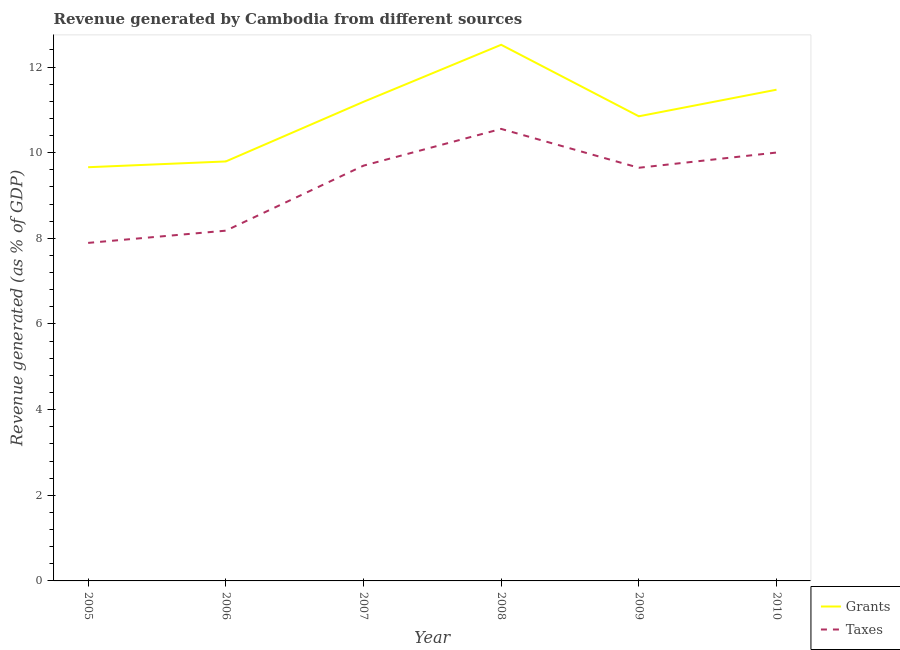How many different coloured lines are there?
Offer a very short reply. 2. Is the number of lines equal to the number of legend labels?
Your response must be concise. Yes. What is the revenue generated by grants in 2006?
Provide a short and direct response. 9.8. Across all years, what is the maximum revenue generated by grants?
Ensure brevity in your answer.  12.52. Across all years, what is the minimum revenue generated by grants?
Ensure brevity in your answer.  9.66. What is the total revenue generated by grants in the graph?
Offer a terse response. 65.48. What is the difference between the revenue generated by taxes in 2006 and that in 2010?
Your response must be concise. -1.82. What is the difference between the revenue generated by grants in 2007 and the revenue generated by taxes in 2010?
Give a very brief answer. 1.18. What is the average revenue generated by taxes per year?
Your answer should be very brief. 9.33. In the year 2008, what is the difference between the revenue generated by grants and revenue generated by taxes?
Offer a very short reply. 1.96. In how many years, is the revenue generated by taxes greater than 4 %?
Provide a short and direct response. 6. What is the ratio of the revenue generated by taxes in 2006 to that in 2007?
Ensure brevity in your answer.  0.84. Is the revenue generated by grants in 2005 less than that in 2006?
Make the answer very short. Yes. Is the difference between the revenue generated by taxes in 2006 and 2008 greater than the difference between the revenue generated by grants in 2006 and 2008?
Provide a short and direct response. Yes. What is the difference between the highest and the second highest revenue generated by grants?
Provide a short and direct response. 1.05. What is the difference between the highest and the lowest revenue generated by taxes?
Keep it short and to the point. 2.66. Is the revenue generated by grants strictly less than the revenue generated by taxes over the years?
Your response must be concise. No. How many lines are there?
Your answer should be compact. 2. How many years are there in the graph?
Keep it short and to the point. 6. Does the graph contain grids?
Make the answer very short. No. Where does the legend appear in the graph?
Ensure brevity in your answer.  Bottom right. How are the legend labels stacked?
Ensure brevity in your answer.  Vertical. What is the title of the graph?
Your answer should be compact. Revenue generated by Cambodia from different sources. What is the label or title of the Y-axis?
Provide a succinct answer. Revenue generated (as % of GDP). What is the Revenue generated (as % of GDP) in Grants in 2005?
Make the answer very short. 9.66. What is the Revenue generated (as % of GDP) of Taxes in 2005?
Offer a terse response. 7.89. What is the Revenue generated (as % of GDP) in Grants in 2006?
Keep it short and to the point. 9.8. What is the Revenue generated (as % of GDP) in Taxes in 2006?
Your answer should be compact. 8.18. What is the Revenue generated (as % of GDP) of Grants in 2007?
Your response must be concise. 11.19. What is the Revenue generated (as % of GDP) of Taxes in 2007?
Your answer should be compact. 9.7. What is the Revenue generated (as % of GDP) of Grants in 2008?
Provide a short and direct response. 12.52. What is the Revenue generated (as % of GDP) of Taxes in 2008?
Provide a succinct answer. 10.56. What is the Revenue generated (as % of GDP) in Grants in 2009?
Make the answer very short. 10.85. What is the Revenue generated (as % of GDP) of Taxes in 2009?
Your answer should be compact. 9.65. What is the Revenue generated (as % of GDP) in Grants in 2010?
Your response must be concise. 11.47. What is the Revenue generated (as % of GDP) of Taxes in 2010?
Offer a terse response. 10. Across all years, what is the maximum Revenue generated (as % of GDP) in Grants?
Give a very brief answer. 12.52. Across all years, what is the maximum Revenue generated (as % of GDP) in Taxes?
Provide a succinct answer. 10.56. Across all years, what is the minimum Revenue generated (as % of GDP) in Grants?
Your answer should be very brief. 9.66. Across all years, what is the minimum Revenue generated (as % of GDP) in Taxes?
Keep it short and to the point. 7.89. What is the total Revenue generated (as % of GDP) in Grants in the graph?
Make the answer very short. 65.48. What is the total Revenue generated (as % of GDP) of Taxes in the graph?
Your answer should be compact. 55.98. What is the difference between the Revenue generated (as % of GDP) in Grants in 2005 and that in 2006?
Give a very brief answer. -0.13. What is the difference between the Revenue generated (as % of GDP) of Taxes in 2005 and that in 2006?
Give a very brief answer. -0.29. What is the difference between the Revenue generated (as % of GDP) of Grants in 2005 and that in 2007?
Provide a succinct answer. -1.53. What is the difference between the Revenue generated (as % of GDP) in Taxes in 2005 and that in 2007?
Offer a terse response. -1.8. What is the difference between the Revenue generated (as % of GDP) of Grants in 2005 and that in 2008?
Your response must be concise. -2.86. What is the difference between the Revenue generated (as % of GDP) of Taxes in 2005 and that in 2008?
Ensure brevity in your answer.  -2.66. What is the difference between the Revenue generated (as % of GDP) of Grants in 2005 and that in 2009?
Offer a terse response. -1.19. What is the difference between the Revenue generated (as % of GDP) in Taxes in 2005 and that in 2009?
Offer a very short reply. -1.75. What is the difference between the Revenue generated (as % of GDP) of Grants in 2005 and that in 2010?
Ensure brevity in your answer.  -1.81. What is the difference between the Revenue generated (as % of GDP) in Taxes in 2005 and that in 2010?
Offer a terse response. -2.11. What is the difference between the Revenue generated (as % of GDP) of Grants in 2006 and that in 2007?
Offer a terse response. -1.39. What is the difference between the Revenue generated (as % of GDP) in Taxes in 2006 and that in 2007?
Provide a short and direct response. -1.52. What is the difference between the Revenue generated (as % of GDP) in Grants in 2006 and that in 2008?
Ensure brevity in your answer.  -2.72. What is the difference between the Revenue generated (as % of GDP) of Taxes in 2006 and that in 2008?
Offer a very short reply. -2.38. What is the difference between the Revenue generated (as % of GDP) of Grants in 2006 and that in 2009?
Ensure brevity in your answer.  -1.05. What is the difference between the Revenue generated (as % of GDP) of Taxes in 2006 and that in 2009?
Make the answer very short. -1.47. What is the difference between the Revenue generated (as % of GDP) of Grants in 2006 and that in 2010?
Offer a terse response. -1.68. What is the difference between the Revenue generated (as % of GDP) in Taxes in 2006 and that in 2010?
Offer a very short reply. -1.82. What is the difference between the Revenue generated (as % of GDP) of Grants in 2007 and that in 2008?
Provide a succinct answer. -1.33. What is the difference between the Revenue generated (as % of GDP) in Taxes in 2007 and that in 2008?
Ensure brevity in your answer.  -0.86. What is the difference between the Revenue generated (as % of GDP) of Grants in 2007 and that in 2009?
Your answer should be very brief. 0.34. What is the difference between the Revenue generated (as % of GDP) of Taxes in 2007 and that in 2009?
Keep it short and to the point. 0.05. What is the difference between the Revenue generated (as % of GDP) of Grants in 2007 and that in 2010?
Make the answer very short. -0.28. What is the difference between the Revenue generated (as % of GDP) of Taxes in 2007 and that in 2010?
Your response must be concise. -0.31. What is the difference between the Revenue generated (as % of GDP) in Grants in 2008 and that in 2009?
Make the answer very short. 1.67. What is the difference between the Revenue generated (as % of GDP) of Taxes in 2008 and that in 2009?
Give a very brief answer. 0.91. What is the difference between the Revenue generated (as % of GDP) in Grants in 2008 and that in 2010?
Keep it short and to the point. 1.05. What is the difference between the Revenue generated (as % of GDP) of Taxes in 2008 and that in 2010?
Your answer should be compact. 0.55. What is the difference between the Revenue generated (as % of GDP) in Grants in 2009 and that in 2010?
Your answer should be very brief. -0.62. What is the difference between the Revenue generated (as % of GDP) in Taxes in 2009 and that in 2010?
Ensure brevity in your answer.  -0.36. What is the difference between the Revenue generated (as % of GDP) of Grants in 2005 and the Revenue generated (as % of GDP) of Taxes in 2006?
Offer a very short reply. 1.48. What is the difference between the Revenue generated (as % of GDP) of Grants in 2005 and the Revenue generated (as % of GDP) of Taxes in 2007?
Make the answer very short. -0.04. What is the difference between the Revenue generated (as % of GDP) in Grants in 2005 and the Revenue generated (as % of GDP) in Taxes in 2008?
Your response must be concise. -0.89. What is the difference between the Revenue generated (as % of GDP) of Grants in 2005 and the Revenue generated (as % of GDP) of Taxes in 2009?
Your response must be concise. 0.01. What is the difference between the Revenue generated (as % of GDP) of Grants in 2005 and the Revenue generated (as % of GDP) of Taxes in 2010?
Keep it short and to the point. -0.34. What is the difference between the Revenue generated (as % of GDP) in Grants in 2006 and the Revenue generated (as % of GDP) in Taxes in 2007?
Give a very brief answer. 0.1. What is the difference between the Revenue generated (as % of GDP) of Grants in 2006 and the Revenue generated (as % of GDP) of Taxes in 2008?
Give a very brief answer. -0.76. What is the difference between the Revenue generated (as % of GDP) of Grants in 2006 and the Revenue generated (as % of GDP) of Taxes in 2009?
Your response must be concise. 0.15. What is the difference between the Revenue generated (as % of GDP) of Grants in 2006 and the Revenue generated (as % of GDP) of Taxes in 2010?
Give a very brief answer. -0.21. What is the difference between the Revenue generated (as % of GDP) of Grants in 2007 and the Revenue generated (as % of GDP) of Taxes in 2008?
Provide a short and direct response. 0.63. What is the difference between the Revenue generated (as % of GDP) of Grants in 2007 and the Revenue generated (as % of GDP) of Taxes in 2009?
Make the answer very short. 1.54. What is the difference between the Revenue generated (as % of GDP) of Grants in 2007 and the Revenue generated (as % of GDP) of Taxes in 2010?
Your answer should be very brief. 1.18. What is the difference between the Revenue generated (as % of GDP) in Grants in 2008 and the Revenue generated (as % of GDP) in Taxes in 2009?
Give a very brief answer. 2.87. What is the difference between the Revenue generated (as % of GDP) in Grants in 2008 and the Revenue generated (as % of GDP) in Taxes in 2010?
Make the answer very short. 2.52. What is the difference between the Revenue generated (as % of GDP) of Grants in 2009 and the Revenue generated (as % of GDP) of Taxes in 2010?
Your answer should be very brief. 0.85. What is the average Revenue generated (as % of GDP) of Grants per year?
Offer a very short reply. 10.91. What is the average Revenue generated (as % of GDP) of Taxes per year?
Your answer should be compact. 9.33. In the year 2005, what is the difference between the Revenue generated (as % of GDP) in Grants and Revenue generated (as % of GDP) in Taxes?
Offer a very short reply. 1.77. In the year 2006, what is the difference between the Revenue generated (as % of GDP) in Grants and Revenue generated (as % of GDP) in Taxes?
Your response must be concise. 1.62. In the year 2007, what is the difference between the Revenue generated (as % of GDP) of Grants and Revenue generated (as % of GDP) of Taxes?
Make the answer very short. 1.49. In the year 2008, what is the difference between the Revenue generated (as % of GDP) of Grants and Revenue generated (as % of GDP) of Taxes?
Give a very brief answer. 1.96. In the year 2009, what is the difference between the Revenue generated (as % of GDP) of Grants and Revenue generated (as % of GDP) of Taxes?
Your answer should be very brief. 1.2. In the year 2010, what is the difference between the Revenue generated (as % of GDP) in Grants and Revenue generated (as % of GDP) in Taxes?
Provide a succinct answer. 1.47. What is the ratio of the Revenue generated (as % of GDP) of Grants in 2005 to that in 2006?
Ensure brevity in your answer.  0.99. What is the ratio of the Revenue generated (as % of GDP) in Taxes in 2005 to that in 2006?
Your response must be concise. 0.97. What is the ratio of the Revenue generated (as % of GDP) of Grants in 2005 to that in 2007?
Provide a succinct answer. 0.86. What is the ratio of the Revenue generated (as % of GDP) of Taxes in 2005 to that in 2007?
Your answer should be very brief. 0.81. What is the ratio of the Revenue generated (as % of GDP) of Grants in 2005 to that in 2008?
Provide a succinct answer. 0.77. What is the ratio of the Revenue generated (as % of GDP) of Taxes in 2005 to that in 2008?
Offer a very short reply. 0.75. What is the ratio of the Revenue generated (as % of GDP) in Grants in 2005 to that in 2009?
Offer a very short reply. 0.89. What is the ratio of the Revenue generated (as % of GDP) in Taxes in 2005 to that in 2009?
Provide a succinct answer. 0.82. What is the ratio of the Revenue generated (as % of GDP) in Grants in 2005 to that in 2010?
Make the answer very short. 0.84. What is the ratio of the Revenue generated (as % of GDP) of Taxes in 2005 to that in 2010?
Ensure brevity in your answer.  0.79. What is the ratio of the Revenue generated (as % of GDP) of Grants in 2006 to that in 2007?
Offer a terse response. 0.88. What is the ratio of the Revenue generated (as % of GDP) in Taxes in 2006 to that in 2007?
Give a very brief answer. 0.84. What is the ratio of the Revenue generated (as % of GDP) of Grants in 2006 to that in 2008?
Give a very brief answer. 0.78. What is the ratio of the Revenue generated (as % of GDP) in Taxes in 2006 to that in 2008?
Offer a very short reply. 0.77. What is the ratio of the Revenue generated (as % of GDP) of Grants in 2006 to that in 2009?
Ensure brevity in your answer.  0.9. What is the ratio of the Revenue generated (as % of GDP) of Taxes in 2006 to that in 2009?
Give a very brief answer. 0.85. What is the ratio of the Revenue generated (as % of GDP) of Grants in 2006 to that in 2010?
Provide a short and direct response. 0.85. What is the ratio of the Revenue generated (as % of GDP) in Taxes in 2006 to that in 2010?
Provide a short and direct response. 0.82. What is the ratio of the Revenue generated (as % of GDP) in Grants in 2007 to that in 2008?
Provide a short and direct response. 0.89. What is the ratio of the Revenue generated (as % of GDP) of Taxes in 2007 to that in 2008?
Make the answer very short. 0.92. What is the ratio of the Revenue generated (as % of GDP) of Grants in 2007 to that in 2009?
Keep it short and to the point. 1.03. What is the ratio of the Revenue generated (as % of GDP) in Grants in 2007 to that in 2010?
Your response must be concise. 0.98. What is the ratio of the Revenue generated (as % of GDP) of Taxes in 2007 to that in 2010?
Offer a terse response. 0.97. What is the ratio of the Revenue generated (as % of GDP) in Grants in 2008 to that in 2009?
Provide a succinct answer. 1.15. What is the ratio of the Revenue generated (as % of GDP) in Taxes in 2008 to that in 2009?
Your answer should be compact. 1.09. What is the ratio of the Revenue generated (as % of GDP) of Grants in 2008 to that in 2010?
Your answer should be compact. 1.09. What is the ratio of the Revenue generated (as % of GDP) in Taxes in 2008 to that in 2010?
Your answer should be very brief. 1.06. What is the ratio of the Revenue generated (as % of GDP) in Grants in 2009 to that in 2010?
Offer a very short reply. 0.95. What is the ratio of the Revenue generated (as % of GDP) of Taxes in 2009 to that in 2010?
Give a very brief answer. 0.96. What is the difference between the highest and the second highest Revenue generated (as % of GDP) in Grants?
Ensure brevity in your answer.  1.05. What is the difference between the highest and the second highest Revenue generated (as % of GDP) in Taxes?
Offer a terse response. 0.55. What is the difference between the highest and the lowest Revenue generated (as % of GDP) in Grants?
Provide a succinct answer. 2.86. What is the difference between the highest and the lowest Revenue generated (as % of GDP) of Taxes?
Provide a short and direct response. 2.66. 